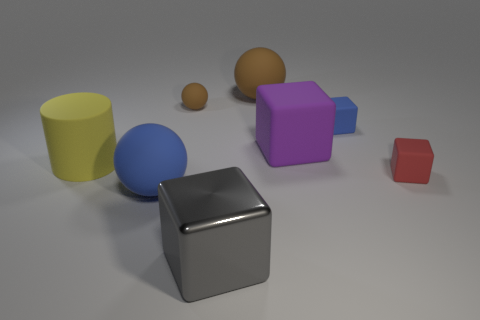Subtract all green cubes. Subtract all purple spheres. How many cubes are left? 4 Add 2 tiny matte balls. How many objects exist? 10 Subtract all spheres. How many objects are left? 5 Subtract all tiny red objects. Subtract all yellow matte cylinders. How many objects are left? 6 Add 2 large purple objects. How many large purple objects are left? 3 Add 3 purple matte objects. How many purple matte objects exist? 4 Subtract 1 purple blocks. How many objects are left? 7 